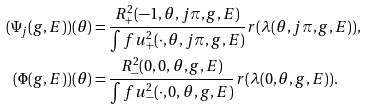<formula> <loc_0><loc_0><loc_500><loc_500>( \Psi _ { j } ( g , E ) ) ( \theta ) & = \frac { R _ { + } ^ { 2 } ( - 1 , \theta , j \pi , g , E ) } { \int f u _ { + } ^ { 2 } ( \cdot , \theta , j \pi , g , E ) } r ( \lambda ( \theta , j \pi , g , E ) ) , \\ ( \Phi ( g , E ) ) ( \theta ) & = \frac { R _ { - } ^ { 2 } ( 0 , 0 , \theta , g , E ) } { \int f u _ { - } ^ { 2 } ( \cdot , 0 , \theta , g , E ) } r ( \lambda ( 0 , \theta , g , E ) ) .</formula> 